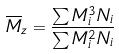Convert formula to latex. <formula><loc_0><loc_0><loc_500><loc_500>\overline { M } _ { z } = \frac { \sum M _ { i } ^ { 3 } N _ { i } } { \sum M _ { i } ^ { 2 } N _ { i } }</formula> 